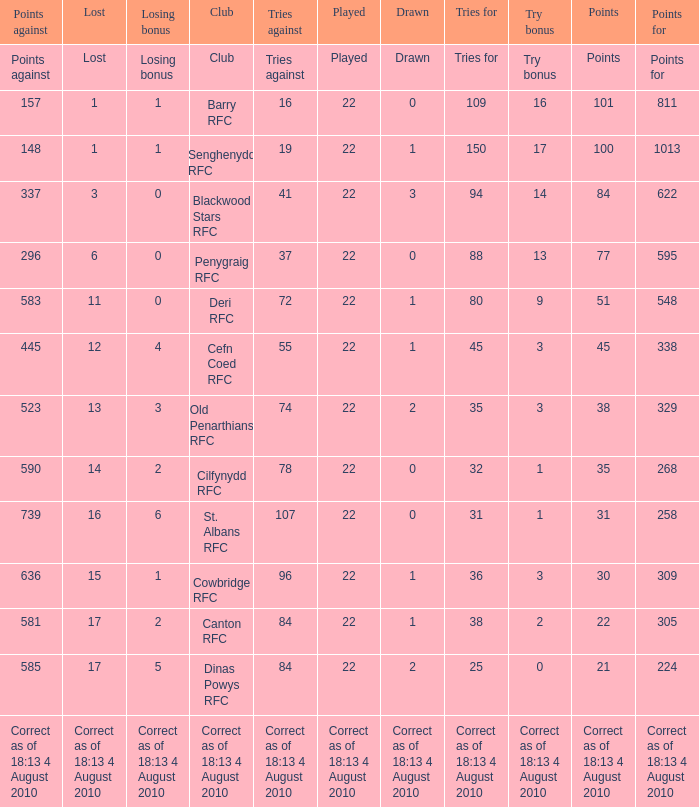Can you identify the club that has accumulated 22 points? Canton RFC. 